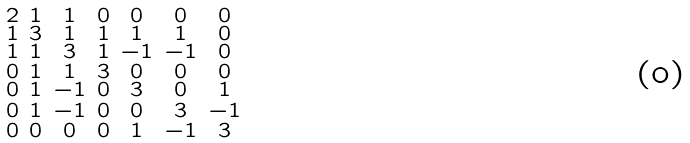Convert formula to latex. <formula><loc_0><loc_0><loc_500><loc_500>\begin{smallmatrix} 2 & 1 & 1 & 0 & 0 & 0 & 0 \\ 1 & 3 & 1 & 1 & 1 & 1 & 0 \\ 1 & 1 & 3 & 1 & - 1 & - 1 & 0 \\ 0 & 1 & 1 & 3 & 0 & 0 & 0 \\ 0 & 1 & - 1 & 0 & 3 & 0 & 1 \\ 0 & 1 & - 1 & 0 & 0 & 3 & - 1 \\ 0 & 0 & 0 & 0 & 1 & - 1 & 3 \end{smallmatrix}</formula> 